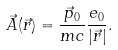Convert formula to latex. <formula><loc_0><loc_0><loc_500><loc_500>\vec { A } ( \vec { r } ) = \frac { \vec { p } _ { 0 } } { m c } \frac { e _ { 0 } } { \left | \vec { r } \right | } .</formula> 